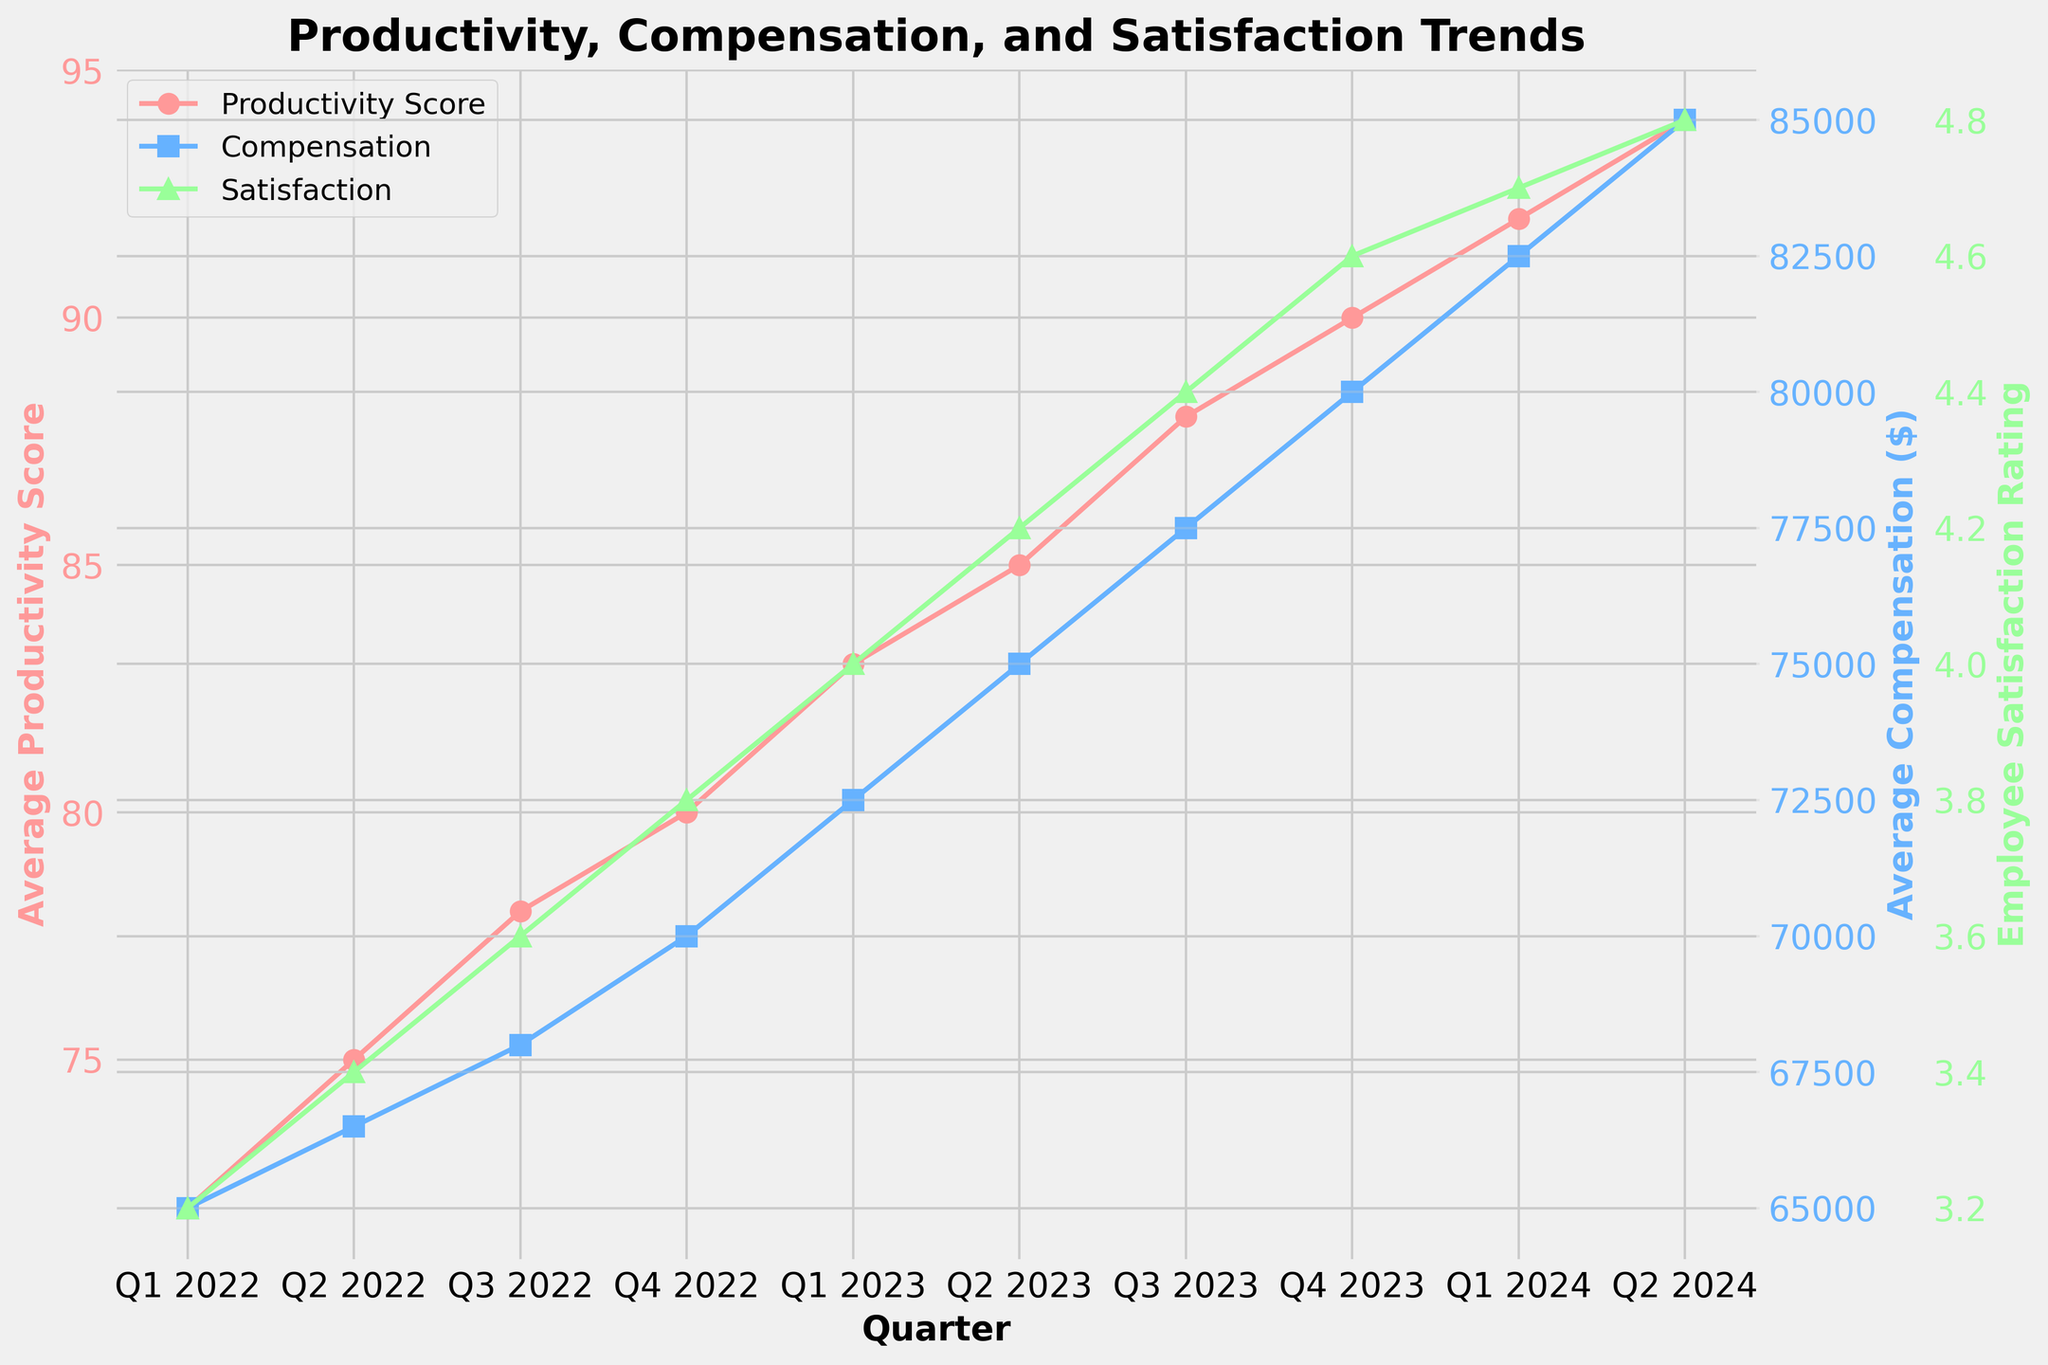What is the trend in average productivity score from Q1 2022 to Q2 2024? To determine the trend, look at how the productivity scores change over the quarters. We see a general increase in the productivity score from 72 in Q1 2022 to 94 in Q2 2024, indicating an upward trend.
Answer: Upward How does the employee satisfaction rating in Q2 2023 compare to Q2 2022? The employee satisfaction rating in Q2 2023 is 4.2, while in Q2 2022 it is 3.4. So, the satisfaction rating has increased by (4.2 - 3.4) = 0.8.
Answer: Q2 2023 is higher Which quarter has the highest average compensation? In the plot, examine the line representing compensation and identify the highest point. The highest compensation is in Q2 2024, where the value reaches 85000.
Answer: Q2 2024 What is the difference in average productivity score between Q4 2022 and Q4 2023? First, find the average productivity scores for Q4 2022 (80) and Q4 2023 (90), then subtract the former from the latter: 90 - 80 = 10.
Answer: 10 By how much did the satisfaction rating improve from Q1 2023 to Q4 2023? The satisfaction rating in Q1 2023 is 4.0 and in Q4 2023 is 4.6. The improvement is calculated as 4.6 - 4.0 = 0.6.
Answer: 0.6 What is the relationship between compensation and productivity scores? Observing the graph shows that as compensation increases, productivity also increases. Both the compensation and productivity lines show an upward trend over the quarters. This indicates a positive correlation between compensation and productivity.
Answer: Positive correlation What color represents the employee satisfaction rating in the graph? Identify the color used for the Satisfaction line in the graph. Based on the code and description, employee satisfaction rating is represented in green.
Answer: Green How much did the average compensation increase from Q1 2022 to Q2 2024? The average compensation in Q1 2022 is 65000, and in Q2 2024 it is 85000. The increase is calculated as 85000 - 65000 = 20000.
Answer: 20000 Compare the rate of increase in average productivity score to the rate of increase in average compensation from Q1 2022 to Q2 2024. To compare rates, calculate the total increase and the number of quarters. Productivity increased by 94 - 72 = 22 points over 10 quarters, and compensation increased by 85000 - 65000 = 20000 over 10 quarters. The average rate of increase per quarter for productivity is 22/10 = 2.2, while for compensation it is 20000/10 = 2000.
Answer: 2.2 points per quarter for productivity, $2000 per quarter for compensation 